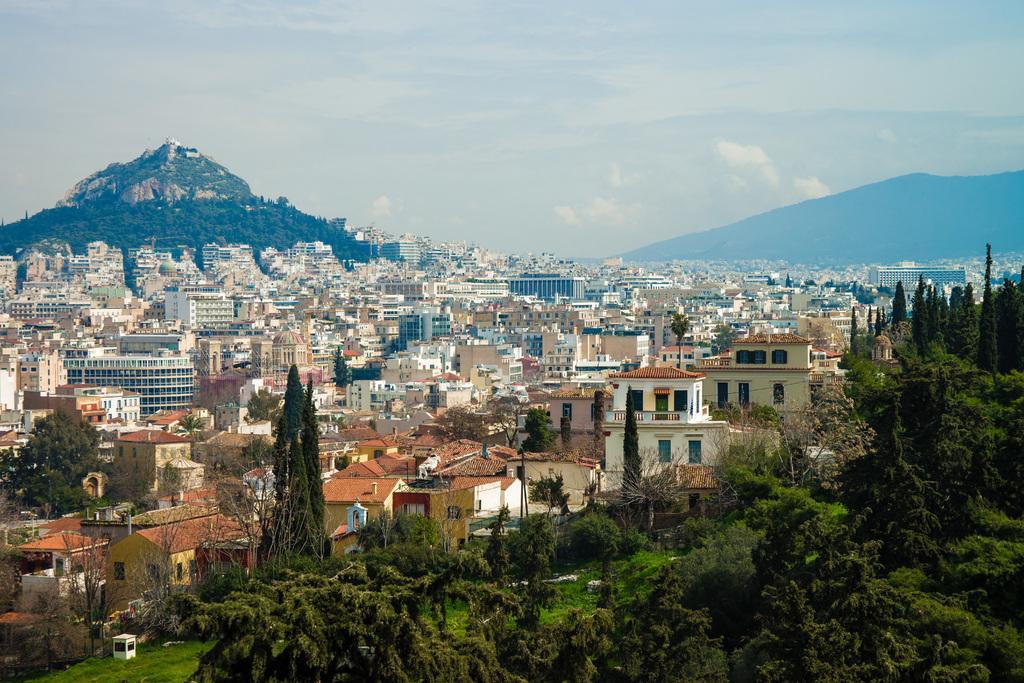Can you describe this image briefly? In this image we can see buildings, mountain, trees. At the top of the image there is sky and clouds. 